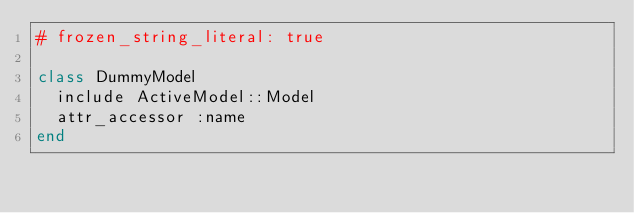<code> <loc_0><loc_0><loc_500><loc_500><_Ruby_># frozen_string_literal: true

class DummyModel
  include ActiveModel::Model
  attr_accessor :name
end
</code> 